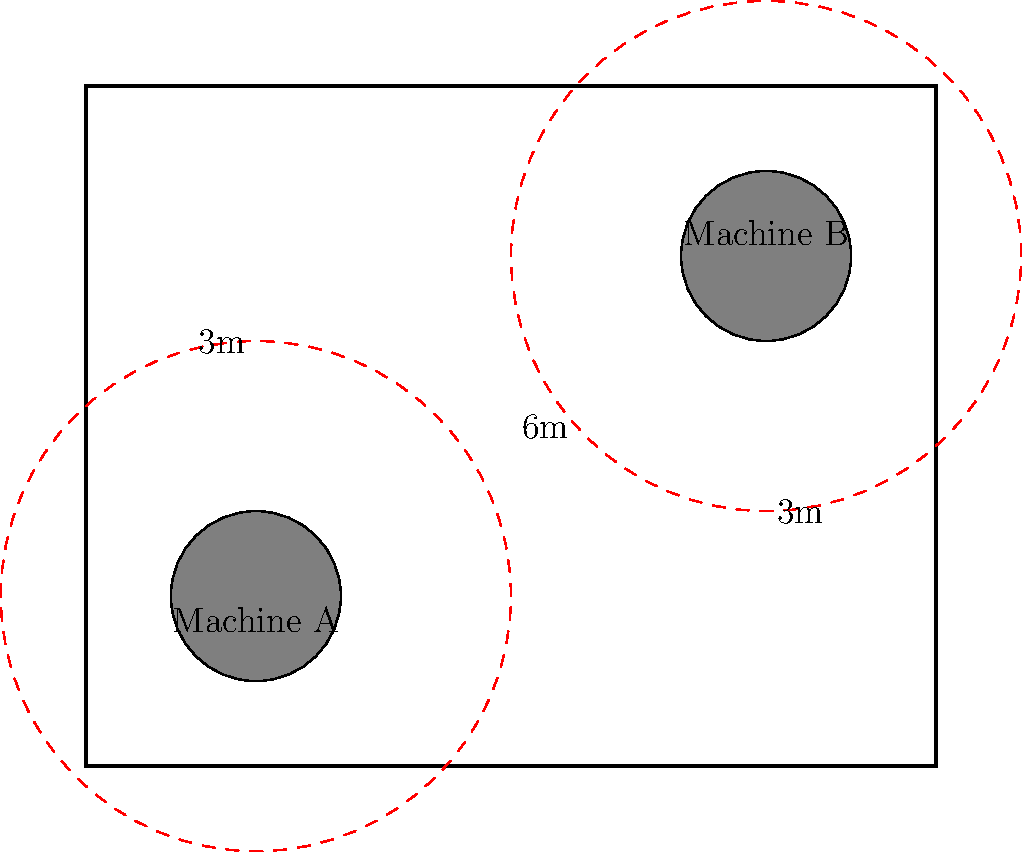In a factory layout, two machines (A and B) are positioned as shown in the diagram. Each machine requires a 3-meter safety zone around it. The distance between the centers of the machines is 6 meters. What is the minimum distance between the edges of their safety zones? To solve this problem, we need to follow these steps:

1. Understand the given information:
   - Machine A and Machine B each have a 3-meter safety zone radius.
   - The distance between the centers of the machines is 6 meters.

2. Calculate the total radius of both safety zones:
   $R_{total} = R_A + R_B = 3m + 3m = 6m$

3. Compare the total radius with the distance between machine centers:
   - Distance between centers = 6m
   - Total radius of safety zones = 6m

4. Calculate the overlap or gap:
   $\text{Overlap/Gap} = \text{Distance between centers} - R_{total}$
   $\text{Overlap/Gap} = 6m - 6m = 0m$

5. Interpret the result:
   - Since the overlap/gap is 0m, the safety zones are exactly touching each other.
   - This means the minimum distance between the edges of their safety zones is 0m.
Answer: 0m 